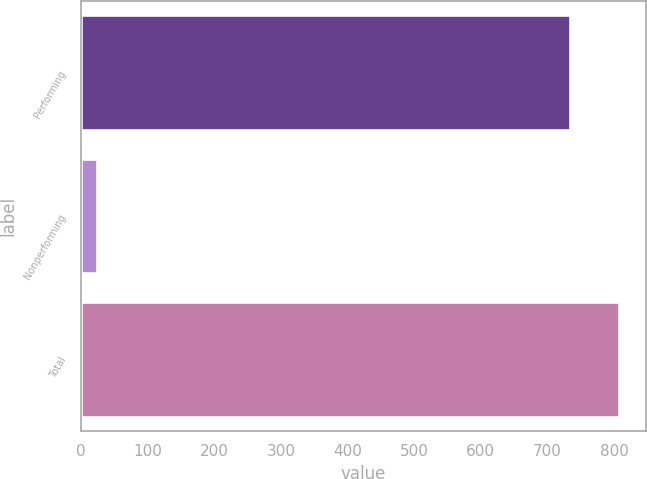<chart> <loc_0><loc_0><loc_500><loc_500><bar_chart><fcel>Performing<fcel>Nonperforming<fcel>Total<nl><fcel>733.7<fcel>23.2<fcel>807.07<nl></chart> 